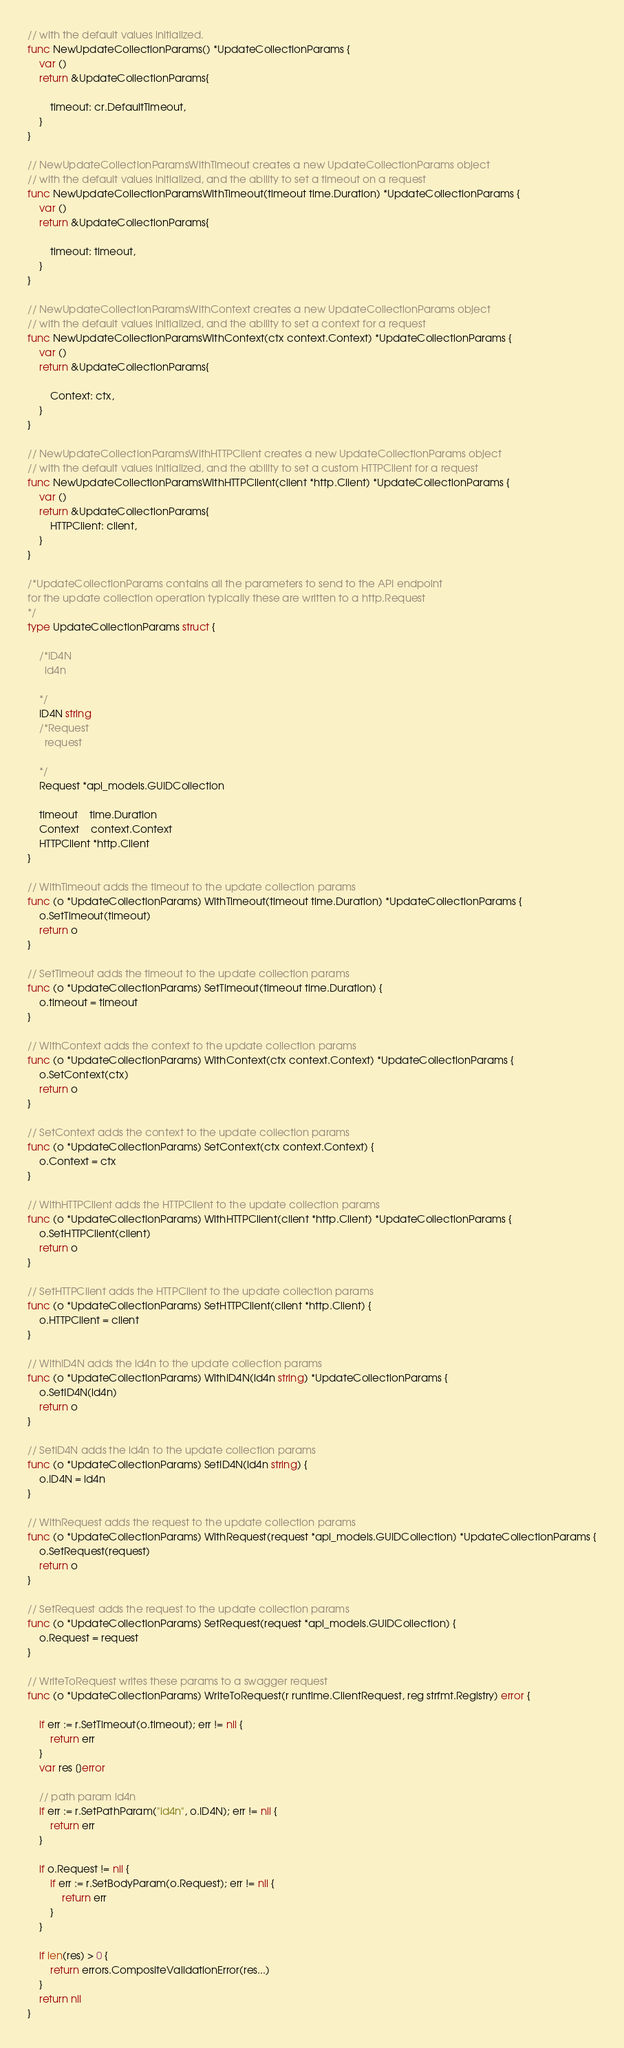<code> <loc_0><loc_0><loc_500><loc_500><_Go_>// with the default values initialized.
func NewUpdateCollectionParams() *UpdateCollectionParams {
	var ()
	return &UpdateCollectionParams{

		timeout: cr.DefaultTimeout,
	}
}

// NewUpdateCollectionParamsWithTimeout creates a new UpdateCollectionParams object
// with the default values initialized, and the ability to set a timeout on a request
func NewUpdateCollectionParamsWithTimeout(timeout time.Duration) *UpdateCollectionParams {
	var ()
	return &UpdateCollectionParams{

		timeout: timeout,
	}
}

// NewUpdateCollectionParamsWithContext creates a new UpdateCollectionParams object
// with the default values initialized, and the ability to set a context for a request
func NewUpdateCollectionParamsWithContext(ctx context.Context) *UpdateCollectionParams {
	var ()
	return &UpdateCollectionParams{

		Context: ctx,
	}
}

// NewUpdateCollectionParamsWithHTTPClient creates a new UpdateCollectionParams object
// with the default values initialized, and the ability to set a custom HTTPClient for a request
func NewUpdateCollectionParamsWithHTTPClient(client *http.Client) *UpdateCollectionParams {
	var ()
	return &UpdateCollectionParams{
		HTTPClient: client,
	}
}

/*UpdateCollectionParams contains all the parameters to send to the API endpoint
for the update collection operation typically these are written to a http.Request
*/
type UpdateCollectionParams struct {

	/*ID4N
	  id4n

	*/
	ID4N string
	/*Request
	  request

	*/
	Request *api_models.GUIDCollection

	timeout    time.Duration
	Context    context.Context
	HTTPClient *http.Client
}

// WithTimeout adds the timeout to the update collection params
func (o *UpdateCollectionParams) WithTimeout(timeout time.Duration) *UpdateCollectionParams {
	o.SetTimeout(timeout)
	return o
}

// SetTimeout adds the timeout to the update collection params
func (o *UpdateCollectionParams) SetTimeout(timeout time.Duration) {
	o.timeout = timeout
}

// WithContext adds the context to the update collection params
func (o *UpdateCollectionParams) WithContext(ctx context.Context) *UpdateCollectionParams {
	o.SetContext(ctx)
	return o
}

// SetContext adds the context to the update collection params
func (o *UpdateCollectionParams) SetContext(ctx context.Context) {
	o.Context = ctx
}

// WithHTTPClient adds the HTTPClient to the update collection params
func (o *UpdateCollectionParams) WithHTTPClient(client *http.Client) *UpdateCollectionParams {
	o.SetHTTPClient(client)
	return o
}

// SetHTTPClient adds the HTTPClient to the update collection params
func (o *UpdateCollectionParams) SetHTTPClient(client *http.Client) {
	o.HTTPClient = client
}

// WithID4N adds the id4n to the update collection params
func (o *UpdateCollectionParams) WithID4N(id4n string) *UpdateCollectionParams {
	o.SetID4N(id4n)
	return o
}

// SetID4N adds the id4n to the update collection params
func (o *UpdateCollectionParams) SetID4N(id4n string) {
	o.ID4N = id4n
}

// WithRequest adds the request to the update collection params
func (o *UpdateCollectionParams) WithRequest(request *api_models.GUIDCollection) *UpdateCollectionParams {
	o.SetRequest(request)
	return o
}

// SetRequest adds the request to the update collection params
func (o *UpdateCollectionParams) SetRequest(request *api_models.GUIDCollection) {
	o.Request = request
}

// WriteToRequest writes these params to a swagger request
func (o *UpdateCollectionParams) WriteToRequest(r runtime.ClientRequest, reg strfmt.Registry) error {

	if err := r.SetTimeout(o.timeout); err != nil {
		return err
	}
	var res []error

	// path param id4n
	if err := r.SetPathParam("id4n", o.ID4N); err != nil {
		return err
	}

	if o.Request != nil {
		if err := r.SetBodyParam(o.Request); err != nil {
			return err
		}
	}

	if len(res) > 0 {
		return errors.CompositeValidationError(res...)
	}
	return nil
}
</code> 